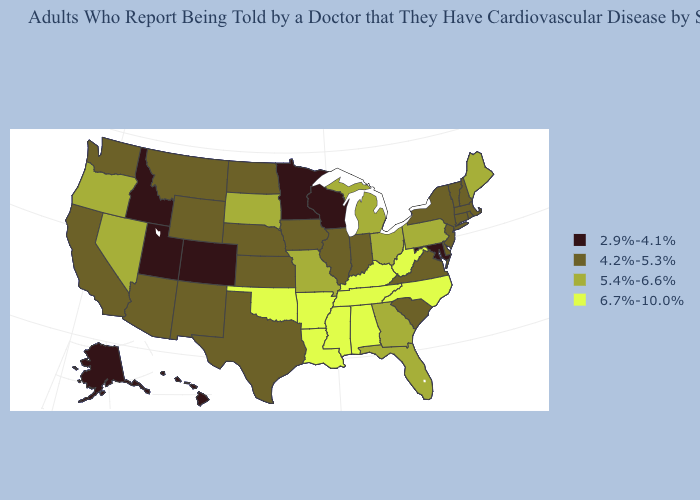Name the states that have a value in the range 2.9%-4.1%?
Be succinct. Alaska, Colorado, Hawaii, Idaho, Maryland, Minnesota, Utah, Wisconsin. Among the states that border Florida , does Alabama have the highest value?
Answer briefly. Yes. Name the states that have a value in the range 6.7%-10.0%?
Concise answer only. Alabama, Arkansas, Kentucky, Louisiana, Mississippi, North Carolina, Oklahoma, Tennessee, West Virginia. How many symbols are there in the legend?
Give a very brief answer. 4. Does North Carolina have the highest value in the USA?
Quick response, please. Yes. Does Arkansas have the highest value in the South?
Quick response, please. Yes. What is the value of Montana?
Quick response, please. 4.2%-5.3%. Name the states that have a value in the range 6.7%-10.0%?
Be succinct. Alabama, Arkansas, Kentucky, Louisiana, Mississippi, North Carolina, Oklahoma, Tennessee, West Virginia. Which states have the lowest value in the USA?
Keep it brief. Alaska, Colorado, Hawaii, Idaho, Maryland, Minnesota, Utah, Wisconsin. What is the highest value in the USA?
Concise answer only. 6.7%-10.0%. Among the states that border Kentucky , does Virginia have the lowest value?
Quick response, please. Yes. Among the states that border Nevada , does Arizona have the lowest value?
Write a very short answer. No. What is the lowest value in the USA?
Write a very short answer. 2.9%-4.1%. Name the states that have a value in the range 6.7%-10.0%?
Answer briefly. Alabama, Arkansas, Kentucky, Louisiana, Mississippi, North Carolina, Oklahoma, Tennessee, West Virginia. Does Illinois have a lower value than Nebraska?
Quick response, please. No. 